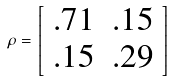Convert formula to latex. <formula><loc_0><loc_0><loc_500><loc_500>\rho = \left [ \begin{array} { c c } . 7 1 & . 1 5 \\ . 1 5 & . 2 9 \\ \end{array} \right ]</formula> 